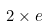Convert formula to latex. <formula><loc_0><loc_0><loc_500><loc_500>2 \times e</formula> 